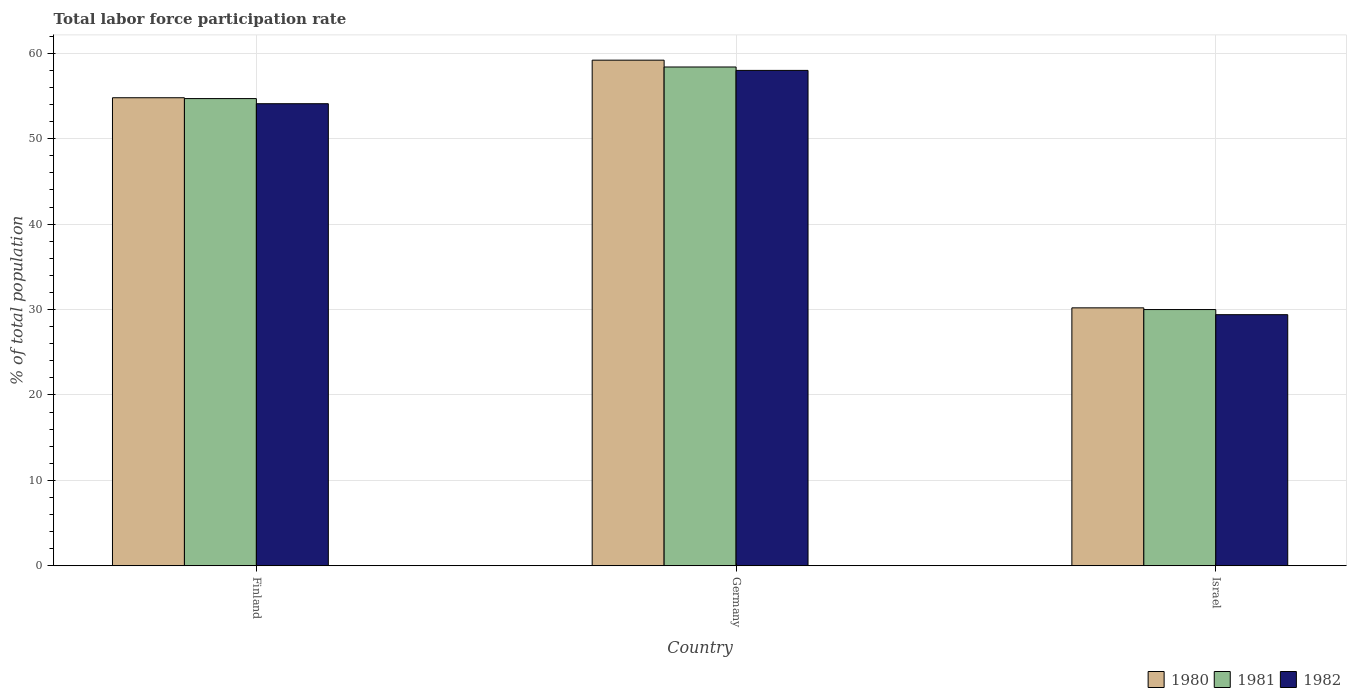How many groups of bars are there?
Make the answer very short. 3. Are the number of bars per tick equal to the number of legend labels?
Ensure brevity in your answer.  Yes. Are the number of bars on each tick of the X-axis equal?
Provide a short and direct response. Yes. How many bars are there on the 2nd tick from the right?
Offer a terse response. 3. What is the label of the 1st group of bars from the left?
Provide a succinct answer. Finland. What is the total labor force participation rate in 1980 in Finland?
Ensure brevity in your answer.  54.8. Across all countries, what is the maximum total labor force participation rate in 1981?
Offer a terse response. 58.4. Across all countries, what is the minimum total labor force participation rate in 1981?
Make the answer very short. 30. In which country was the total labor force participation rate in 1981 minimum?
Your response must be concise. Israel. What is the total total labor force participation rate in 1981 in the graph?
Offer a very short reply. 143.1. What is the difference between the total labor force participation rate in 1982 in Finland and that in Germany?
Your answer should be very brief. -3.9. What is the difference between the total labor force participation rate in 1981 in Germany and the total labor force participation rate in 1982 in Finland?
Ensure brevity in your answer.  4.3. What is the average total labor force participation rate in 1980 per country?
Your response must be concise. 48.07. What is the difference between the total labor force participation rate of/in 1982 and total labor force participation rate of/in 1981 in Israel?
Offer a terse response. -0.6. What is the ratio of the total labor force participation rate in 1980 in Germany to that in Israel?
Offer a very short reply. 1.96. What is the difference between the highest and the second highest total labor force participation rate in 1981?
Provide a succinct answer. 3.7. What is the difference between the highest and the lowest total labor force participation rate in 1980?
Ensure brevity in your answer.  29. In how many countries, is the total labor force participation rate in 1981 greater than the average total labor force participation rate in 1981 taken over all countries?
Your answer should be very brief. 2. Is the sum of the total labor force participation rate in 1981 in Finland and Germany greater than the maximum total labor force participation rate in 1980 across all countries?
Your response must be concise. Yes. What does the 1st bar from the left in Finland represents?
Provide a succinct answer. 1980. What does the 3rd bar from the right in Israel represents?
Keep it short and to the point. 1980. Is it the case that in every country, the sum of the total labor force participation rate in 1982 and total labor force participation rate in 1980 is greater than the total labor force participation rate in 1981?
Make the answer very short. Yes. What is the difference between two consecutive major ticks on the Y-axis?
Give a very brief answer. 10. Are the values on the major ticks of Y-axis written in scientific E-notation?
Provide a short and direct response. No. Does the graph contain any zero values?
Ensure brevity in your answer.  No. Does the graph contain grids?
Ensure brevity in your answer.  Yes. How are the legend labels stacked?
Provide a short and direct response. Horizontal. What is the title of the graph?
Give a very brief answer. Total labor force participation rate. What is the label or title of the Y-axis?
Your response must be concise. % of total population. What is the % of total population of 1980 in Finland?
Ensure brevity in your answer.  54.8. What is the % of total population in 1981 in Finland?
Your response must be concise. 54.7. What is the % of total population in 1982 in Finland?
Your answer should be compact. 54.1. What is the % of total population in 1980 in Germany?
Ensure brevity in your answer.  59.2. What is the % of total population in 1981 in Germany?
Make the answer very short. 58.4. What is the % of total population of 1980 in Israel?
Offer a very short reply. 30.2. What is the % of total population of 1981 in Israel?
Make the answer very short. 30. What is the % of total population in 1982 in Israel?
Offer a terse response. 29.4. Across all countries, what is the maximum % of total population in 1980?
Provide a short and direct response. 59.2. Across all countries, what is the maximum % of total population of 1981?
Offer a terse response. 58.4. Across all countries, what is the maximum % of total population of 1982?
Make the answer very short. 58. Across all countries, what is the minimum % of total population in 1980?
Your answer should be very brief. 30.2. Across all countries, what is the minimum % of total population in 1982?
Offer a very short reply. 29.4. What is the total % of total population of 1980 in the graph?
Keep it short and to the point. 144.2. What is the total % of total population in 1981 in the graph?
Give a very brief answer. 143.1. What is the total % of total population in 1982 in the graph?
Your response must be concise. 141.5. What is the difference between the % of total population of 1980 in Finland and that in Germany?
Keep it short and to the point. -4.4. What is the difference between the % of total population of 1981 in Finland and that in Germany?
Ensure brevity in your answer.  -3.7. What is the difference between the % of total population of 1980 in Finland and that in Israel?
Make the answer very short. 24.6. What is the difference between the % of total population of 1981 in Finland and that in Israel?
Provide a short and direct response. 24.7. What is the difference between the % of total population of 1982 in Finland and that in Israel?
Your response must be concise. 24.7. What is the difference between the % of total population of 1980 in Germany and that in Israel?
Make the answer very short. 29. What is the difference between the % of total population of 1981 in Germany and that in Israel?
Your answer should be compact. 28.4. What is the difference between the % of total population in 1982 in Germany and that in Israel?
Your answer should be compact. 28.6. What is the difference between the % of total population in 1980 in Finland and the % of total population in 1981 in Germany?
Provide a succinct answer. -3.6. What is the difference between the % of total population of 1981 in Finland and the % of total population of 1982 in Germany?
Provide a short and direct response. -3.3. What is the difference between the % of total population of 1980 in Finland and the % of total population of 1981 in Israel?
Your answer should be very brief. 24.8. What is the difference between the % of total population of 1980 in Finland and the % of total population of 1982 in Israel?
Provide a succinct answer. 25.4. What is the difference between the % of total population of 1981 in Finland and the % of total population of 1982 in Israel?
Your response must be concise. 25.3. What is the difference between the % of total population in 1980 in Germany and the % of total population in 1981 in Israel?
Your answer should be compact. 29.2. What is the difference between the % of total population in 1980 in Germany and the % of total population in 1982 in Israel?
Make the answer very short. 29.8. What is the average % of total population of 1980 per country?
Your answer should be compact. 48.07. What is the average % of total population in 1981 per country?
Offer a very short reply. 47.7. What is the average % of total population of 1982 per country?
Your answer should be very brief. 47.17. What is the difference between the % of total population of 1980 and % of total population of 1981 in Finland?
Make the answer very short. 0.1. What is the difference between the % of total population in 1980 and % of total population in 1981 in Germany?
Keep it short and to the point. 0.8. What is the difference between the % of total population in 1980 and % of total population in 1982 in Germany?
Offer a terse response. 1.2. What is the difference between the % of total population of 1981 and % of total population of 1982 in Germany?
Your answer should be compact. 0.4. What is the difference between the % of total population in 1980 and % of total population in 1981 in Israel?
Offer a terse response. 0.2. What is the difference between the % of total population in 1980 and % of total population in 1982 in Israel?
Provide a short and direct response. 0.8. What is the difference between the % of total population in 1981 and % of total population in 1982 in Israel?
Offer a terse response. 0.6. What is the ratio of the % of total population of 1980 in Finland to that in Germany?
Give a very brief answer. 0.93. What is the ratio of the % of total population of 1981 in Finland to that in Germany?
Your response must be concise. 0.94. What is the ratio of the % of total population in 1982 in Finland to that in Germany?
Make the answer very short. 0.93. What is the ratio of the % of total population of 1980 in Finland to that in Israel?
Provide a short and direct response. 1.81. What is the ratio of the % of total population in 1981 in Finland to that in Israel?
Offer a terse response. 1.82. What is the ratio of the % of total population of 1982 in Finland to that in Israel?
Provide a short and direct response. 1.84. What is the ratio of the % of total population of 1980 in Germany to that in Israel?
Offer a very short reply. 1.96. What is the ratio of the % of total population of 1981 in Germany to that in Israel?
Your answer should be compact. 1.95. What is the ratio of the % of total population of 1982 in Germany to that in Israel?
Your response must be concise. 1.97. What is the difference between the highest and the lowest % of total population of 1980?
Offer a very short reply. 29. What is the difference between the highest and the lowest % of total population in 1981?
Offer a terse response. 28.4. What is the difference between the highest and the lowest % of total population of 1982?
Your answer should be very brief. 28.6. 